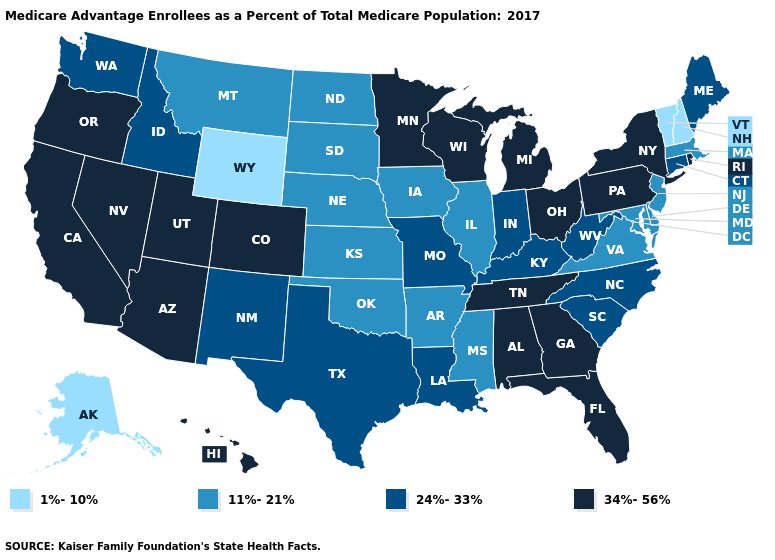What is the value of Colorado?
Short answer required. 34%-56%. Among the states that border North Carolina , which have the lowest value?
Concise answer only. Virginia. Does Nebraska have the highest value in the USA?
Keep it brief. No. Which states hav the highest value in the South?
Write a very short answer. Alabama, Florida, Georgia, Tennessee. What is the value of Mississippi?
Quick response, please. 11%-21%. What is the lowest value in states that border Kansas?
Concise answer only. 11%-21%. What is the value of Georgia?
Be succinct. 34%-56%. Name the states that have a value in the range 1%-10%?
Concise answer only. Alaska, New Hampshire, Vermont, Wyoming. Name the states that have a value in the range 1%-10%?
Concise answer only. Alaska, New Hampshire, Vermont, Wyoming. Which states have the lowest value in the West?
Be succinct. Alaska, Wyoming. Which states have the highest value in the USA?
Keep it brief. Alabama, Arizona, California, Colorado, Florida, Georgia, Hawaii, Michigan, Minnesota, Nevada, New York, Ohio, Oregon, Pennsylvania, Rhode Island, Tennessee, Utah, Wisconsin. Does the first symbol in the legend represent the smallest category?
Concise answer only. Yes. Which states hav the highest value in the Northeast?
Concise answer only. New York, Pennsylvania, Rhode Island. Does Louisiana have the highest value in the South?
Give a very brief answer. No. What is the value of Arizona?
Write a very short answer. 34%-56%. 